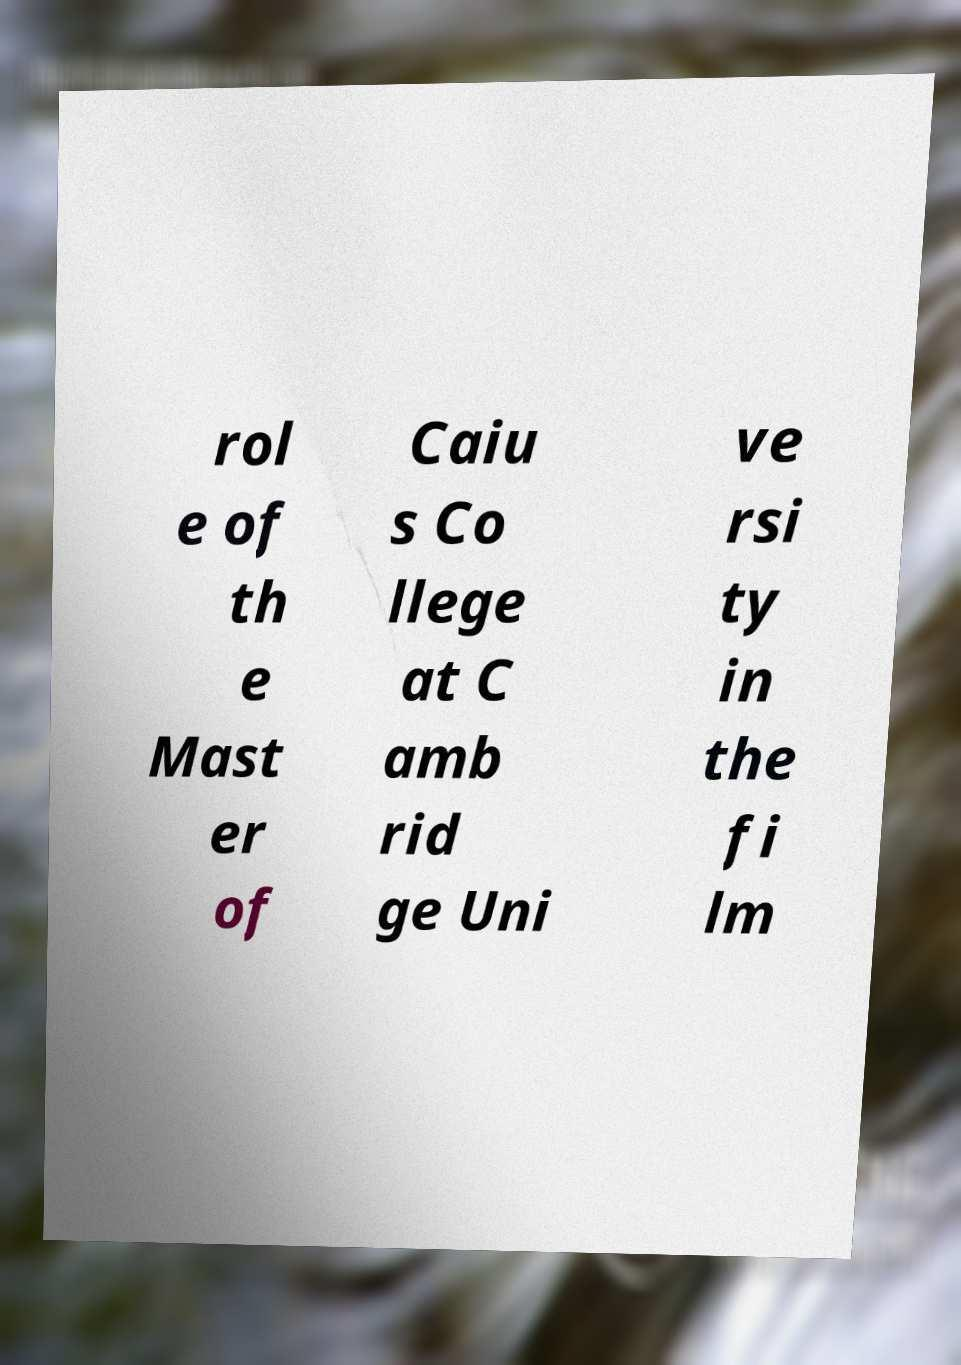Can you read and provide the text displayed in the image?This photo seems to have some interesting text. Can you extract and type it out for me? rol e of th e Mast er of Caiu s Co llege at C amb rid ge Uni ve rsi ty in the fi lm 